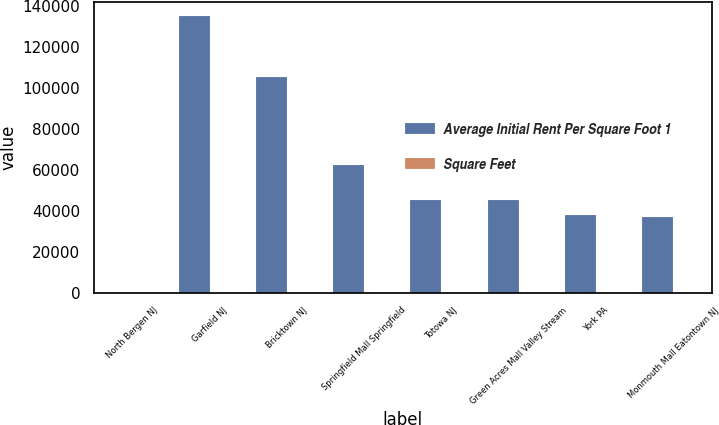Convert chart. <chart><loc_0><loc_0><loc_500><loc_500><stacked_bar_chart><ecel><fcel>North Bergen NJ<fcel>Garfield NJ<fcel>Bricktown NJ<fcel>Springfield Mall Springfield<fcel>Totowa NJ<fcel>Green Acres Mall Valley Stream<fcel>York PA<fcel>Monmouth Mall Eatontown NJ<nl><fcel>Average Initial Rent Per Square Foot 1<fcel>36.02<fcel>135000<fcel>105000<fcel>62000<fcel>45000<fcel>45000<fcel>38000<fcel>37000<nl><fcel>Square Feet<fcel>15.61<fcel>7.41<fcel>13.22<fcel>20.72<fcel>16.24<fcel>36.02<fcel>7.7<fcel>34.22<nl></chart> 